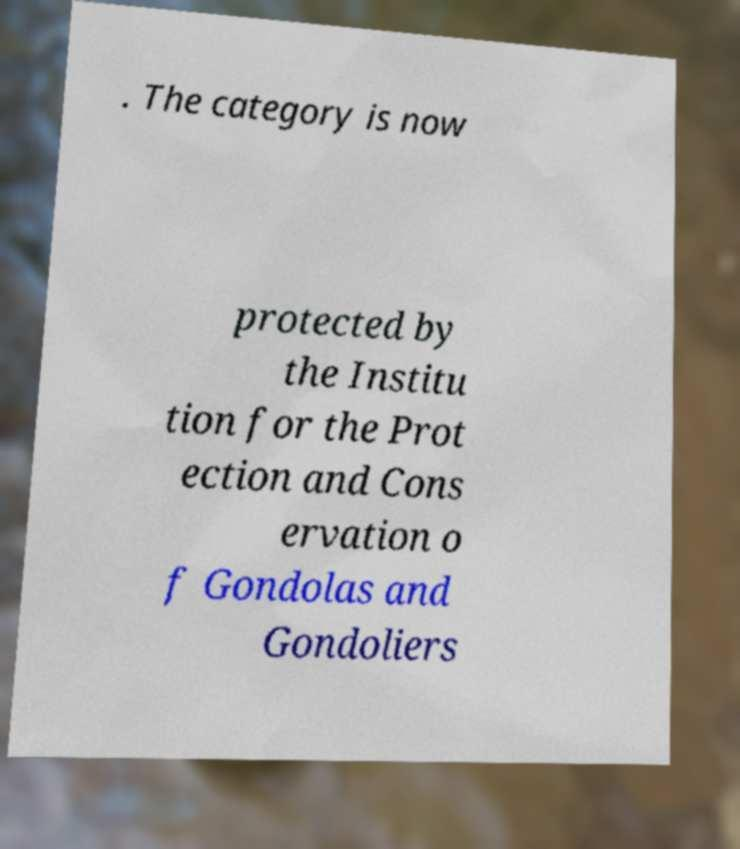Can you accurately transcribe the text from the provided image for me? . The category is now protected by the Institu tion for the Prot ection and Cons ervation o f Gondolas and Gondoliers 